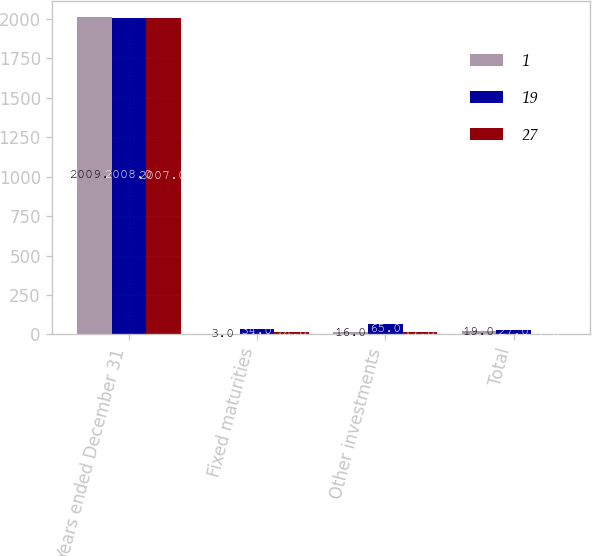Convert chart. <chart><loc_0><loc_0><loc_500><loc_500><stacked_bar_chart><ecel><fcel>Years ended December 31<fcel>Fixed maturities<fcel>Other investments<fcel>Total<nl><fcel>1<fcel>2009<fcel>3<fcel>16<fcel>19<nl><fcel>19<fcel>2008<fcel>34<fcel>65<fcel>27<nl><fcel>27<fcel>2007<fcel>18<fcel>17<fcel>1<nl></chart> 